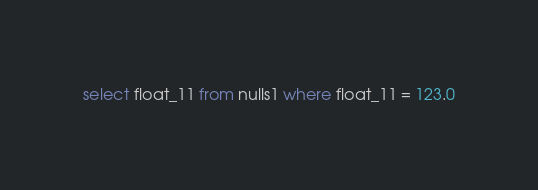<code> <loc_0><loc_0><loc_500><loc_500><_SQL_>select float_11 from nulls1 where float_11 = 123.0
</code> 